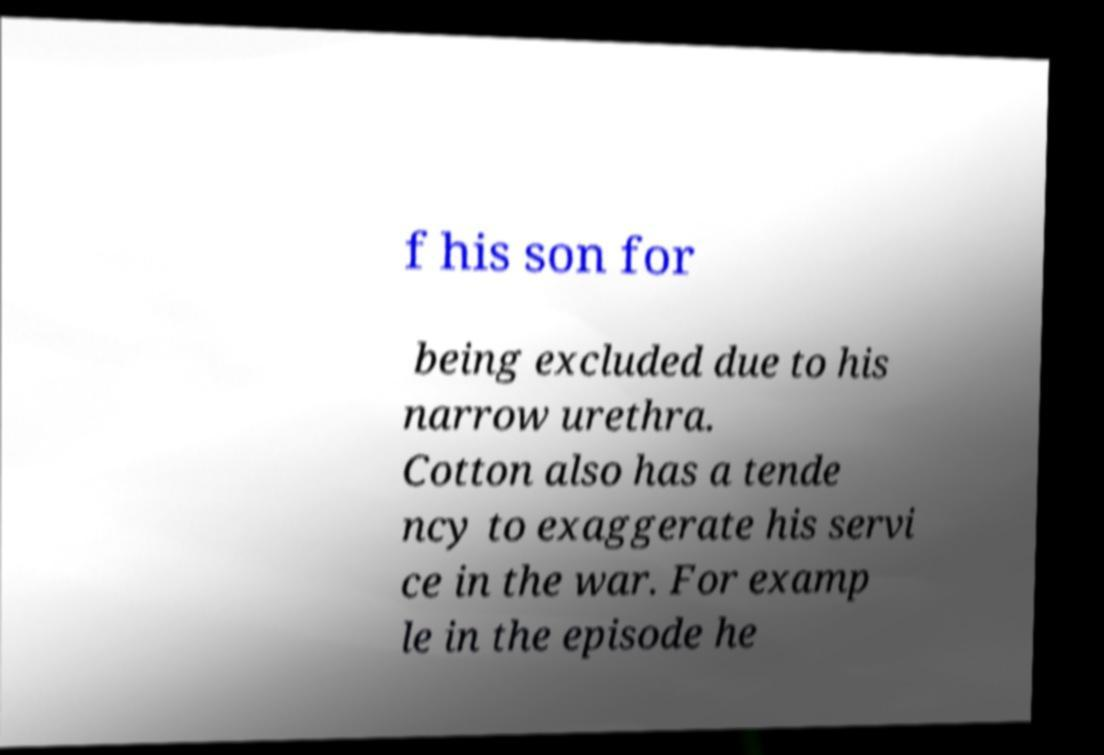Can you accurately transcribe the text from the provided image for me? f his son for being excluded due to his narrow urethra. Cotton also has a tende ncy to exaggerate his servi ce in the war. For examp le in the episode he 